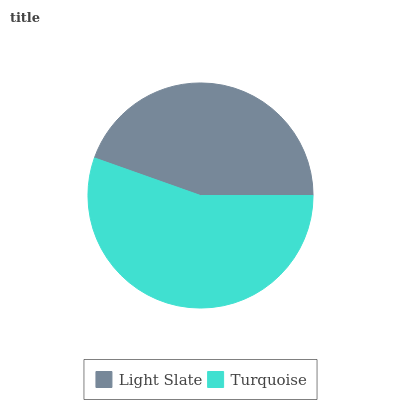Is Light Slate the minimum?
Answer yes or no. Yes. Is Turquoise the maximum?
Answer yes or no. Yes. Is Turquoise the minimum?
Answer yes or no. No. Is Turquoise greater than Light Slate?
Answer yes or no. Yes. Is Light Slate less than Turquoise?
Answer yes or no. Yes. Is Light Slate greater than Turquoise?
Answer yes or no. No. Is Turquoise less than Light Slate?
Answer yes or no. No. Is Turquoise the high median?
Answer yes or no. Yes. Is Light Slate the low median?
Answer yes or no. Yes. Is Light Slate the high median?
Answer yes or no. No. Is Turquoise the low median?
Answer yes or no. No. 